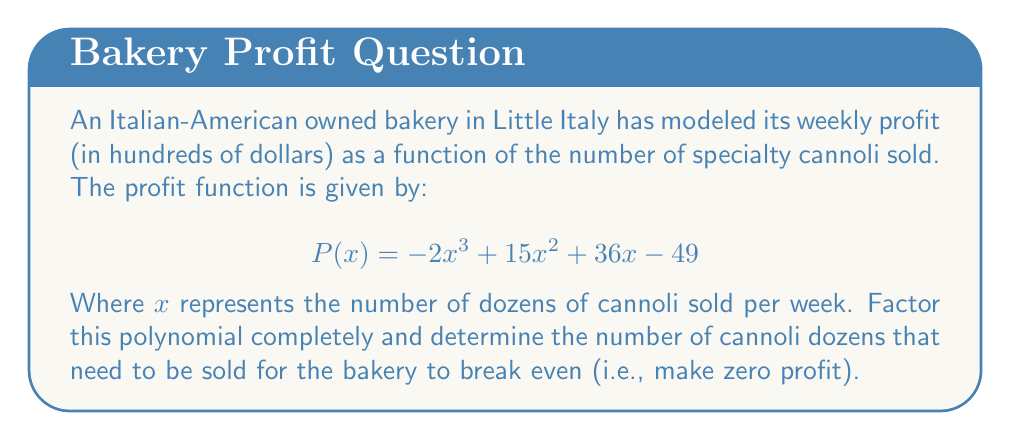Give your solution to this math problem. To solve this problem, we need to factor the polynomial and find the roots. The steps are as follows:

1) First, let's check if there's a common factor:
   There is no common factor for all terms.

2) Next, we can try to factor by grouping:
   $$P(x) = -2x^3 + 15x^2 + 36x - 49$$
   $$= (-2x^3 + 15x^2) + (36x - 49)$$
   $$= x^2(-2x + 15) + 1(36x - 49)$$

3) We can factor out $(x - 7)$ from both groups:
   $$= (x^2)(x - 7) + (1)(36x - 49)$$
   $$= (x^2 + 36)(x - 7)$$

4) The quadratic term $(x^2 + 36)$ cannot be factored further as it has no real roots.

5) Therefore, the complete factorization is:
   $$P(x) = (x^2 + 36)(x - 7)$$

6) To find where the profit is zero, we set $P(x) = 0$:
   $$(x^2 + 36)(x - 7) = 0$$

7) Solving this equation:
   Either $x^2 + 36 = 0$ or $x - 7 = 0$
   $x^2 = -36$ (no real solution) or $x = 7$

8) The only real solution is $x = 7$, which means the bakery breaks even when they sell 7 dozen cannoli per week.
Answer: The completely factored polynomial is $P(x) = (x^2 + 36)(x - 7)$. The bakery breaks even when they sell 7 dozen cannoli per week. 